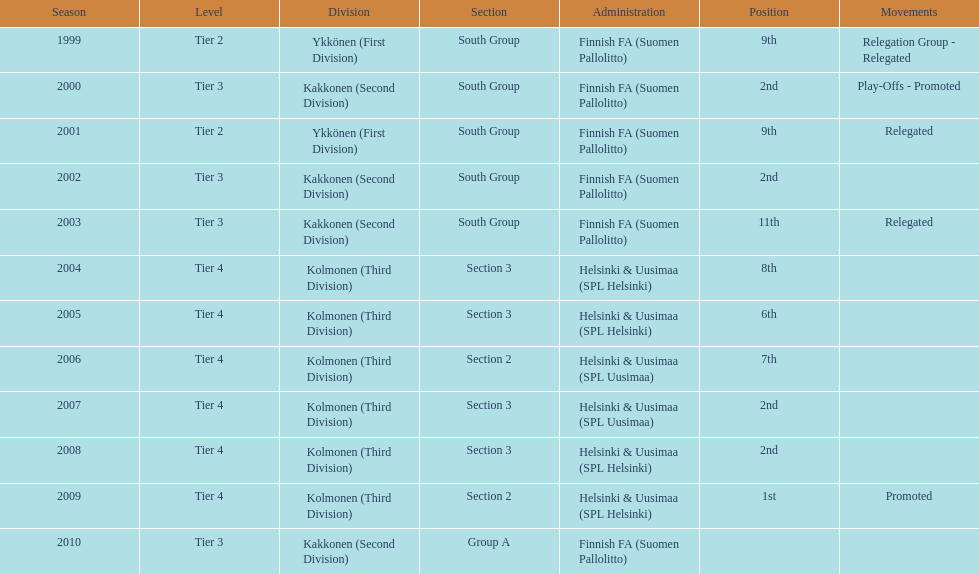What division were they in the most, section 3 or 2? 3. 